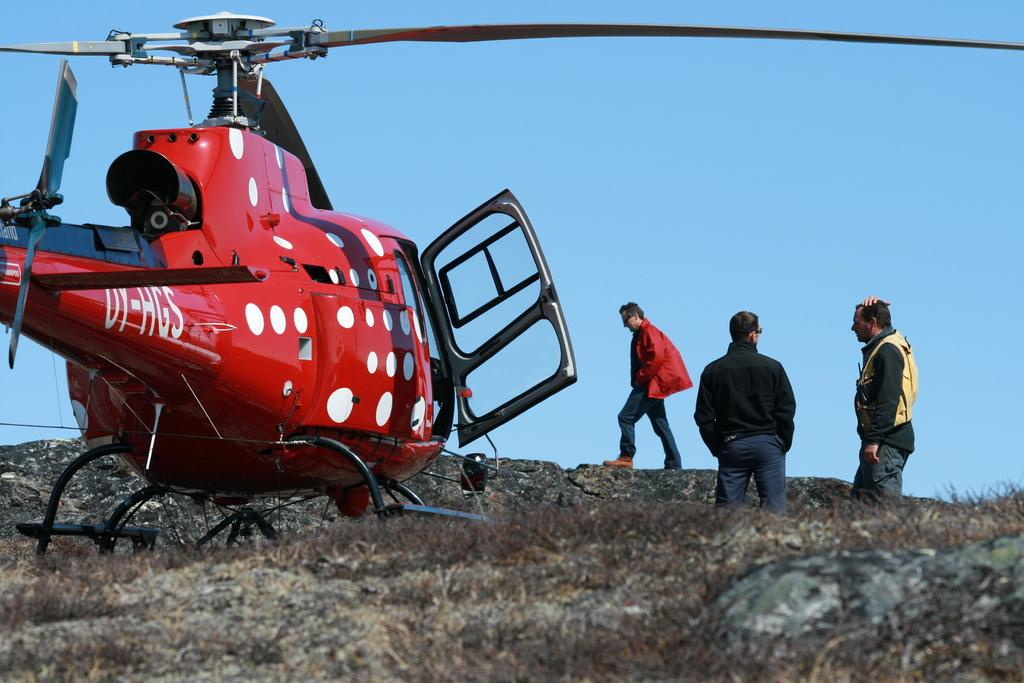What is the main subject of the image? The main subject of the image is a helicopter. Can you describe the colors of the helicopter? The helicopter is red, white, and black in color. How many men are in the image? There are three men in the image. What are the men wearing? The men are wearing clothes. What type of terrain is visible in the image? There is dry grass in the image. What other object can be seen in the image? There is a rock in the image. What is the color of the sky in the image? The sky is pale blue. What shape is the turkey in the image? There is no turkey present in the image. How do the men plan to join the helicopter in the image? The men are not shown attempting to join the helicopter in the image. 